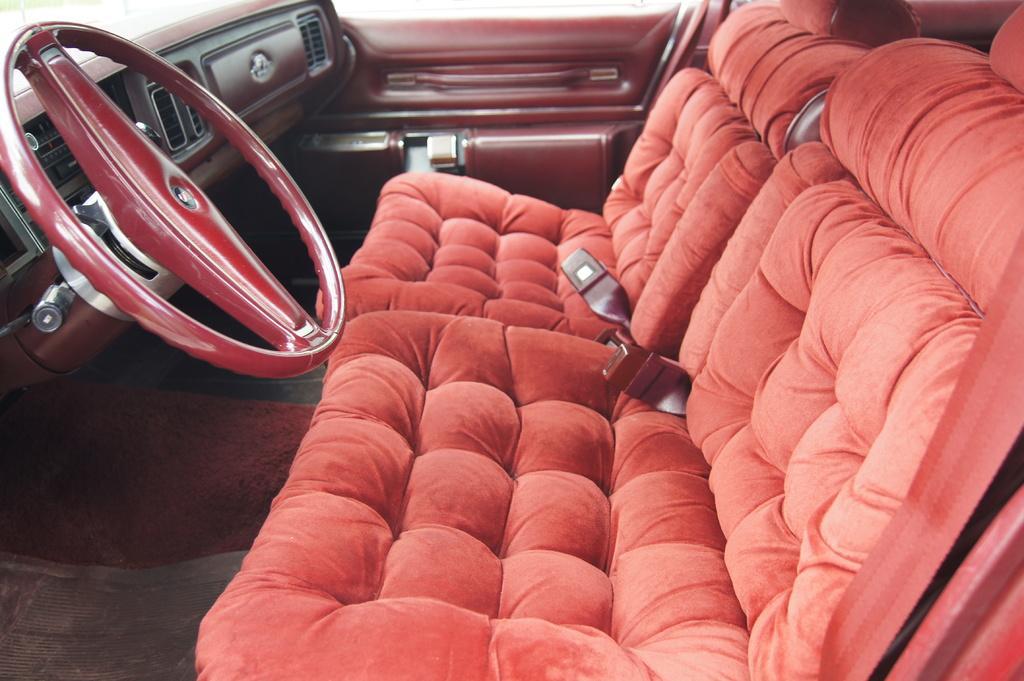Could you give a brief overview of what you see in this image? This is the inside view of a vehicle. Here we can see seats and a steering. 